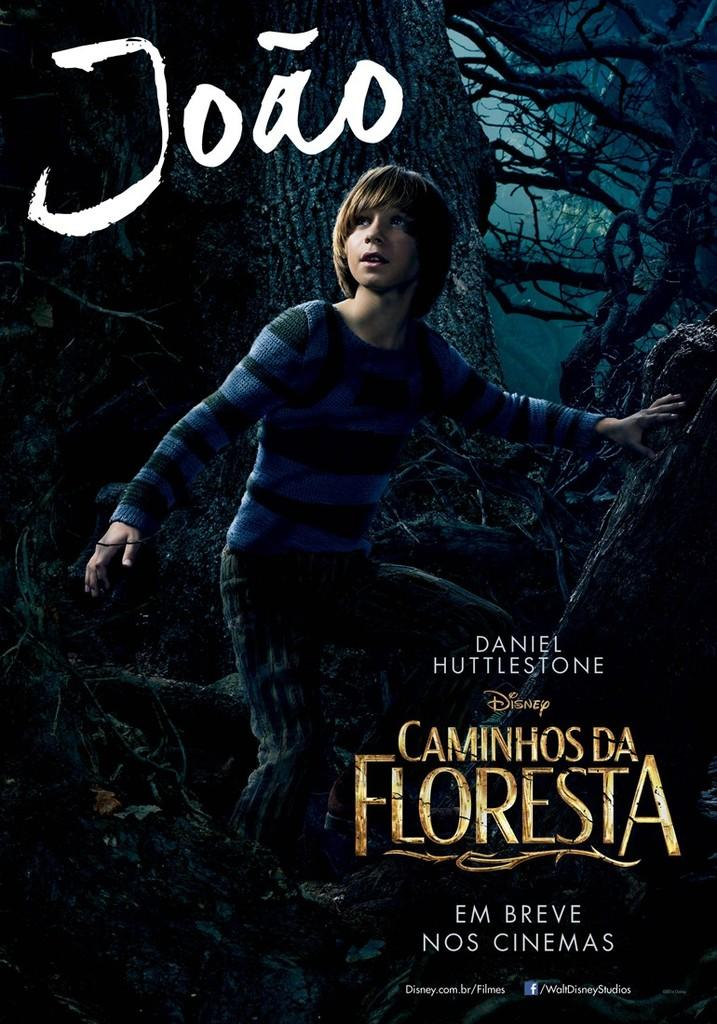<image>
Give a short and clear explanation of the subsequent image. a disney movie poster for the movie 'caminhos da floresta' 